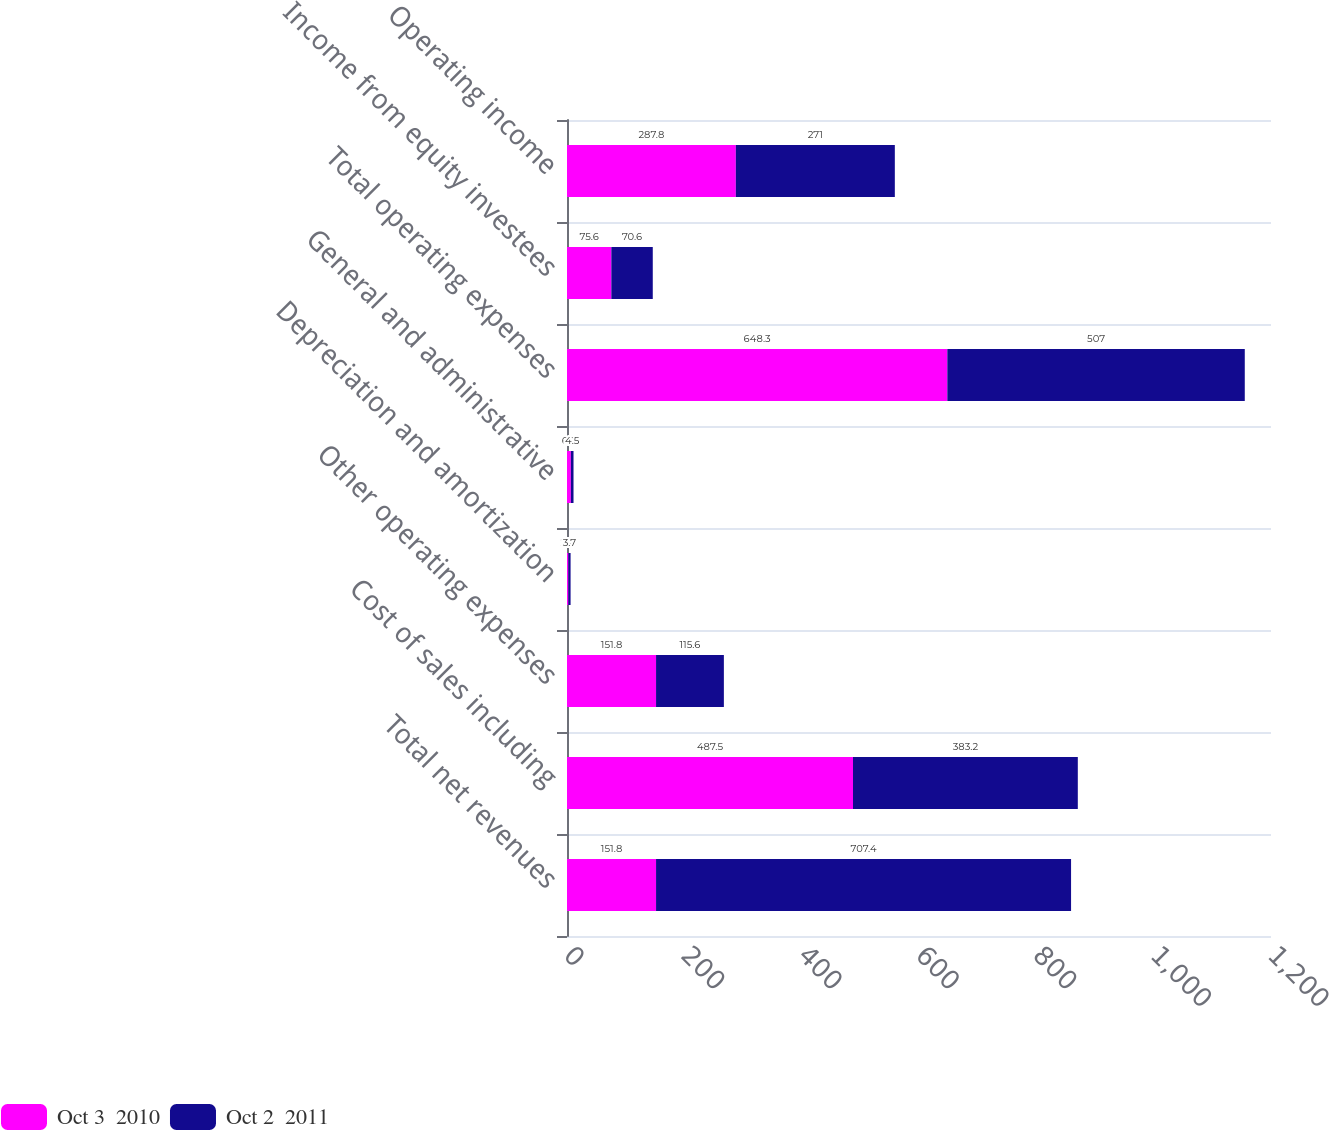Convert chart to OTSL. <chart><loc_0><loc_0><loc_500><loc_500><stacked_bar_chart><ecel><fcel>Total net revenues<fcel>Cost of sales including<fcel>Other operating expenses<fcel>Depreciation and amortization<fcel>General and administrative<fcel>Total operating expenses<fcel>Income from equity investees<fcel>Operating income<nl><fcel>Oct 3  2010<fcel>151.8<fcel>487.5<fcel>151.8<fcel>2.4<fcel>6.6<fcel>648.3<fcel>75.6<fcel>287.8<nl><fcel>Oct 2  2011<fcel>707.4<fcel>383.2<fcel>115.6<fcel>3.7<fcel>4.5<fcel>507<fcel>70.6<fcel>271<nl></chart> 